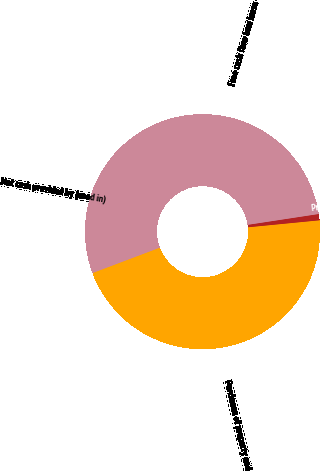Convert chart. <chart><loc_0><loc_0><loc_500><loc_500><pie_chart><fcel>Net cash provided by (used in)<fcel>Purchases of property and<fcel>Principal repayments of<fcel>Free cash flow less lease<nl><fcel>17.1%<fcel>45.81%<fcel>0.86%<fcel>36.24%<nl></chart> 